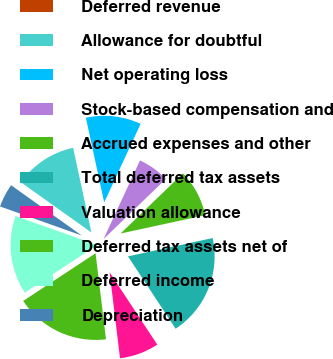<chart> <loc_0><loc_0><loc_500><loc_500><pie_chart><fcel>Deferred revenue<fcel>Allowance for doubtful<fcel>Net operating loss<fcel>Stock-based compensation and<fcel>Accrued expenses and other<fcel>Total deferred tax assets<fcel>Valuation allowance<fcel>Deferred tax assets net of<fcel>Deferred income<fcel>Depreciation<nl><fcel>0.0%<fcel>11.76%<fcel>10.29%<fcel>5.88%<fcel>8.82%<fcel>19.11%<fcel>7.35%<fcel>17.64%<fcel>14.7%<fcel>4.41%<nl></chart> 